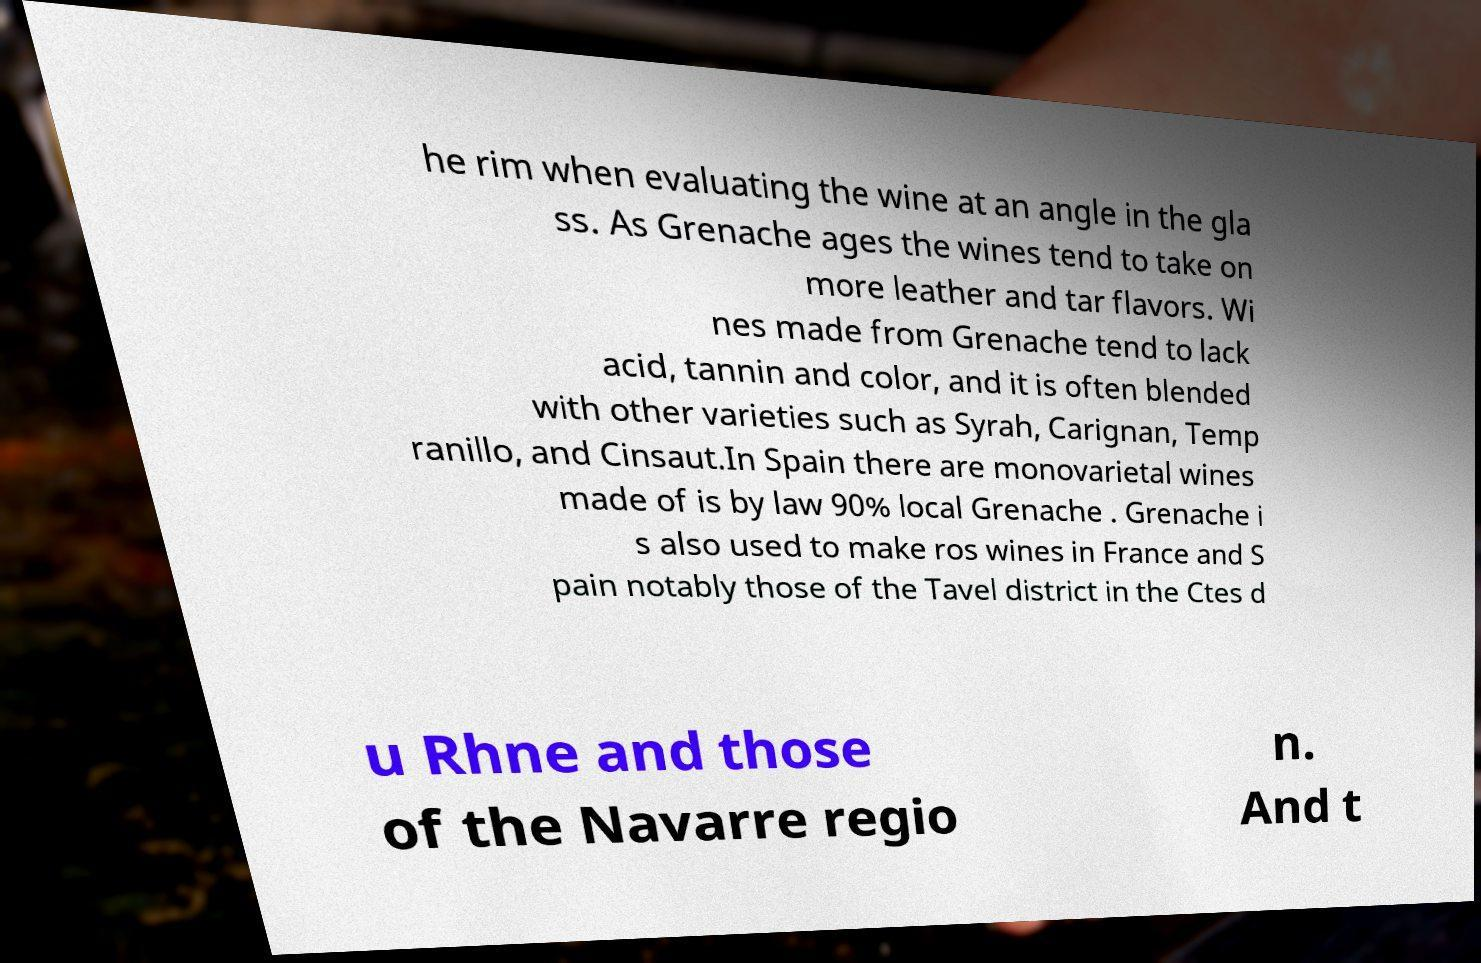Can you accurately transcribe the text from the provided image for me? he rim when evaluating the wine at an angle in the gla ss. As Grenache ages the wines tend to take on more leather and tar flavors. Wi nes made from Grenache tend to lack acid, tannin and color, and it is often blended with other varieties such as Syrah, Carignan, Temp ranillo, and Cinsaut.In Spain there are monovarietal wines made of is by law 90% local Grenache . Grenache i s also used to make ros wines in France and S pain notably those of the Tavel district in the Ctes d u Rhne and those of the Navarre regio n. And t 